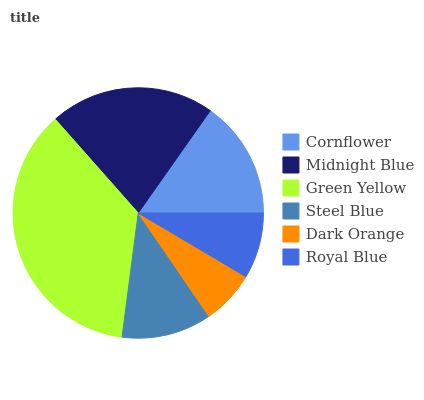Is Dark Orange the minimum?
Answer yes or no. Yes. Is Green Yellow the maximum?
Answer yes or no. Yes. Is Midnight Blue the minimum?
Answer yes or no. No. Is Midnight Blue the maximum?
Answer yes or no. No. Is Midnight Blue greater than Cornflower?
Answer yes or no. Yes. Is Cornflower less than Midnight Blue?
Answer yes or no. Yes. Is Cornflower greater than Midnight Blue?
Answer yes or no. No. Is Midnight Blue less than Cornflower?
Answer yes or no. No. Is Cornflower the high median?
Answer yes or no. Yes. Is Steel Blue the low median?
Answer yes or no. Yes. Is Royal Blue the high median?
Answer yes or no. No. Is Green Yellow the low median?
Answer yes or no. No. 